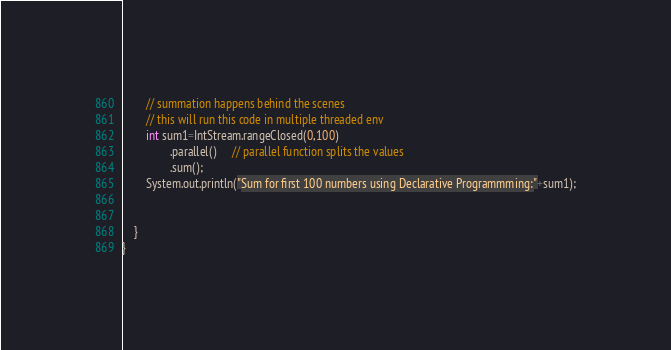<code> <loc_0><loc_0><loc_500><loc_500><_Java_>        // summation happens behind the scenes
        // this will run this code in multiple threaded env
        int sum1=IntStream.rangeClosed(0,100)
                .parallel()     // parallel function splits the values
                .sum();
        System.out.println("Sum for first 100 numbers using Declarative Programmming:"+sum1);


    }
}
</code> 